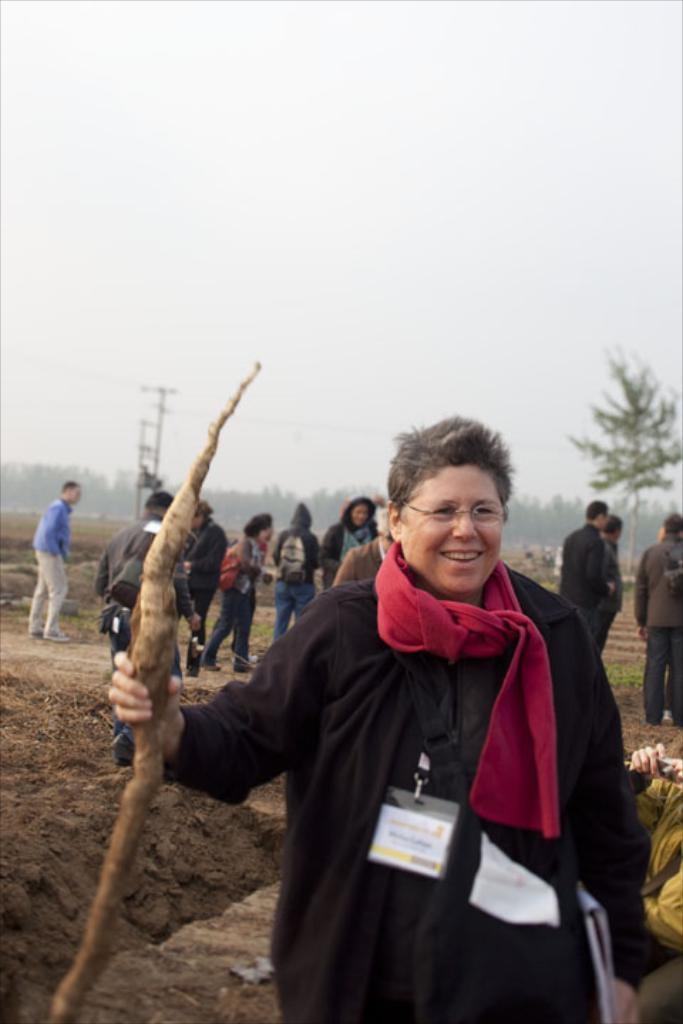What is the main subject of the image? There is a person standing in the center of the image. What is the person holding in the image? The person is holding a stick. What can be seen in the background of the image? There are people, trees, poles, and the sky visible in the background of the image. What type of curtain is hanging from the poles in the image? There are no curtains present in the image; only trees and poles are visible in the background. What game are the people in the background playing in the image? There is no game being played in the image; the people in the background are not engaged in any specific activity. 